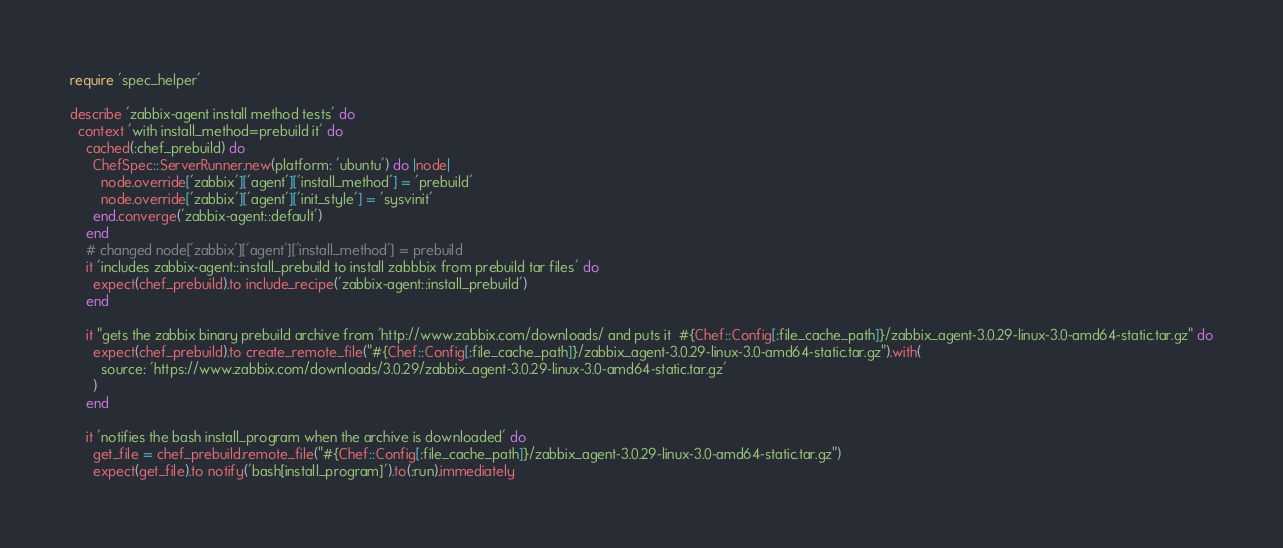<code> <loc_0><loc_0><loc_500><loc_500><_Ruby_>require 'spec_helper'

describe 'zabbix-agent install method tests' do
  context 'with install_method=prebuild it' do
    cached(:chef_prebuild) do
      ChefSpec::ServerRunner.new(platform: 'ubuntu') do |node|
        node.override['zabbix']['agent']['install_method'] = 'prebuild'
        node.override['zabbix']['agent']['init_style'] = 'sysvinit'
      end.converge('zabbix-agent::default')
    end
    # changed node['zabbix']['agent']['install_method'] = prebuild
    it 'includes zabbix-agent::install_prebuild to install zabbbix from prebuild tar files' do
      expect(chef_prebuild).to include_recipe('zabbix-agent::install_prebuild')
    end

    it "gets the zabbix binary prebuild archive from 'http://www.zabbix.com/downloads/ and puts it  #{Chef::Config[:file_cache_path]}/zabbix_agent-3.0.29-linux-3.0-amd64-static.tar.gz" do
      expect(chef_prebuild).to create_remote_file("#{Chef::Config[:file_cache_path]}/zabbix_agent-3.0.29-linux-3.0-amd64-static.tar.gz").with(
        source: 'https://www.zabbix.com/downloads/3.0.29/zabbix_agent-3.0.29-linux-3.0-amd64-static.tar.gz'
      )
    end

    it 'notifies the bash install_program when the archive is downloaded' do
      get_file = chef_prebuild.remote_file("#{Chef::Config[:file_cache_path]}/zabbix_agent-3.0.29-linux-3.0-amd64-static.tar.gz")
      expect(get_file).to notify('bash[install_program]').to(:run).immediately</code> 